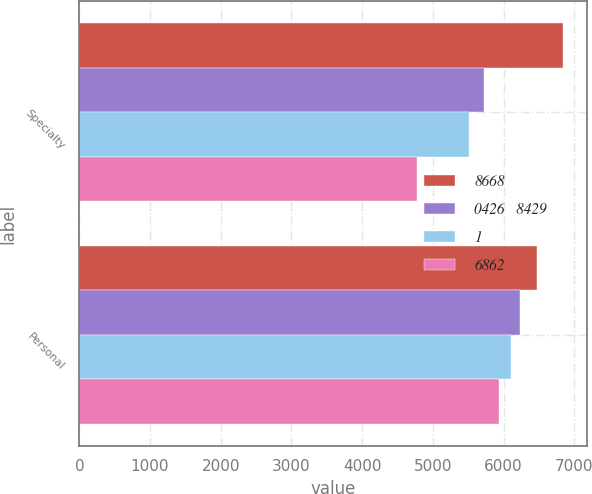Convert chart to OTSL. <chart><loc_0><loc_0><loc_500><loc_500><stacked_bar_chart><ecel><fcel>Specialty<fcel>Personal<nl><fcel>8668<fcel>6836<fcel>6474<nl><fcel>0426   8429<fcel>5729<fcel>6228<nl><fcel>1<fcel>5511<fcel>6111<nl><fcel>6862<fcel>4771<fcel>5929<nl></chart> 